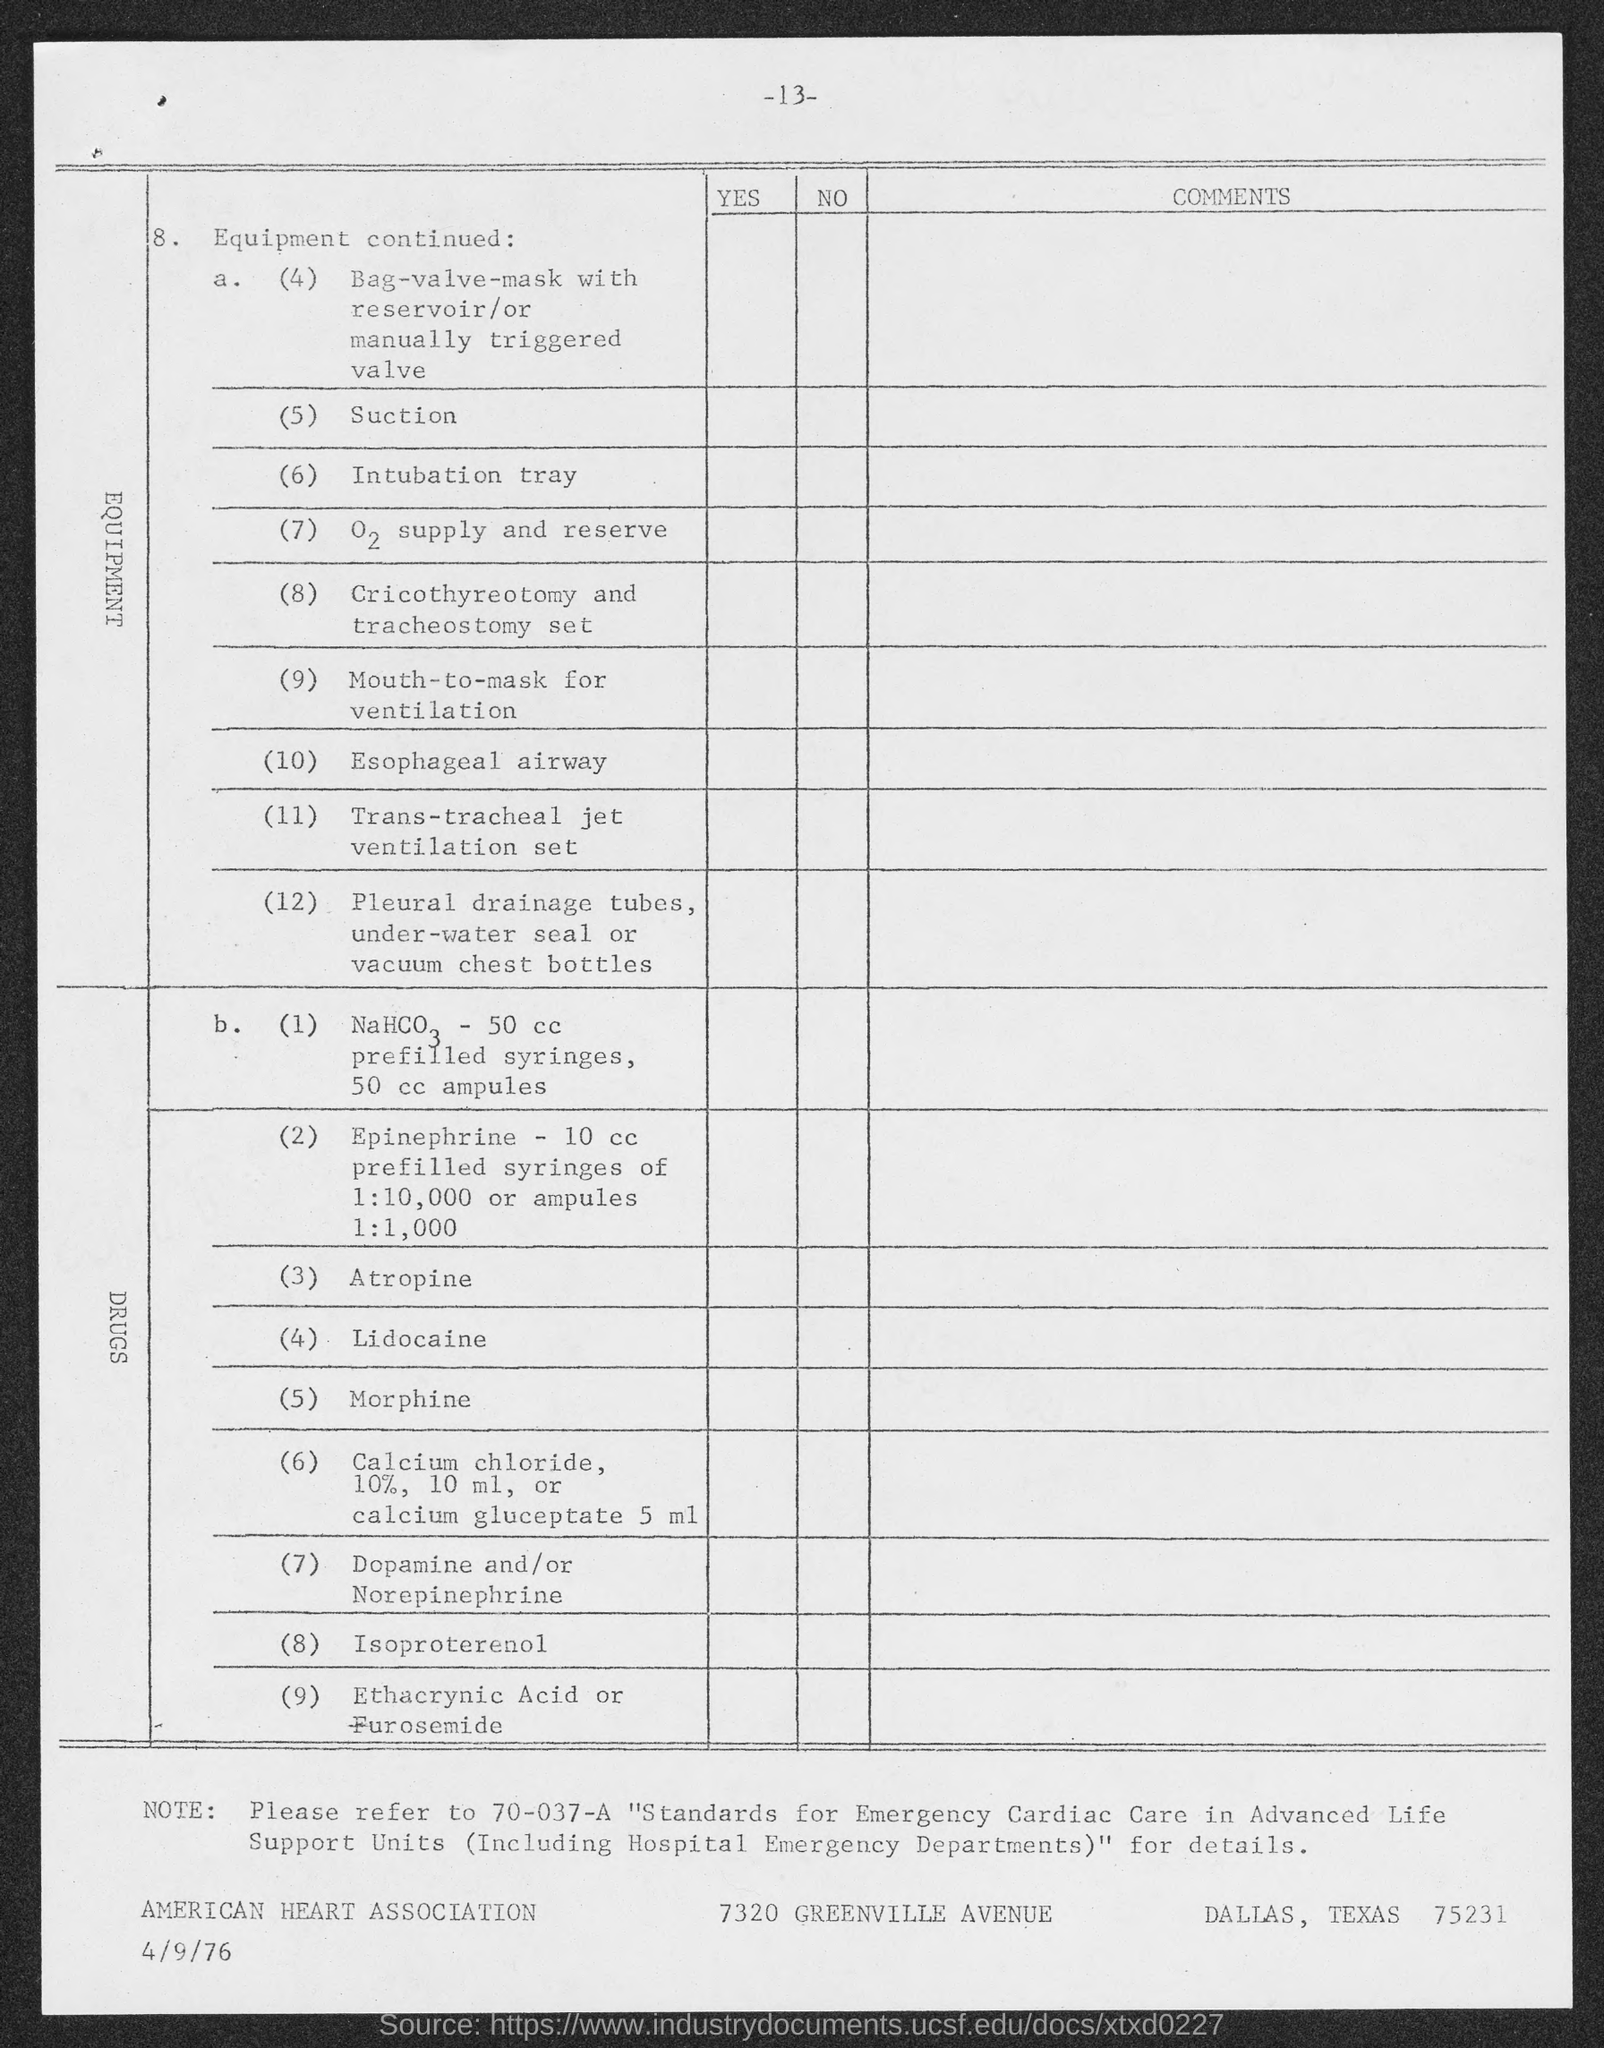What is the number at top of the page ?
Your answer should be very brief. -13-. 